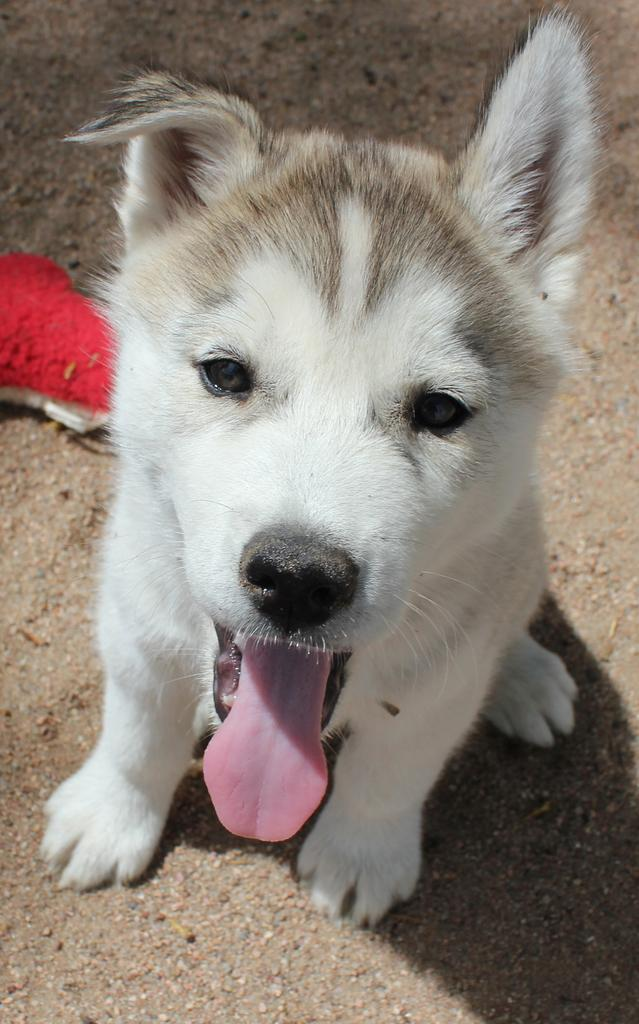What is the main subject in the center of the image? There is a dog in the center of the image. What can be seen on the left side of the image? There is an object on the left side of the image. What is visible in the background of the image? The ground is visible in the background of the image. Can you tell me how many friends the dog has in the image? There is no indication of any friends in the image; it only shows a dog and an object on the left side. What type of jelly is being used to create the image? There is no mention of jelly being used to create the image; it is a photograph or digital representation. 